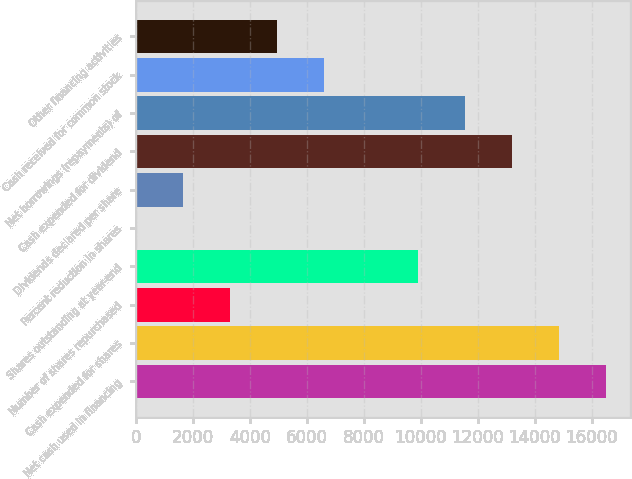Convert chart to OTSL. <chart><loc_0><loc_0><loc_500><loc_500><bar_chart><fcel>Net cash used in financing<fcel>Cash expended for shares<fcel>Number of shares repurchased<fcel>Shares outstanding at year-end<fcel>Percent reduction in shares<fcel>Dividends declared per share<fcel>Cash expended for dividend<fcel>Net borrowings (repayments) of<fcel>Cash received for common stock<fcel>Other financing activities<nl><fcel>16504<fcel>14853.8<fcel>3302.4<fcel>9903.2<fcel>2<fcel>1652.2<fcel>13203.6<fcel>11553.4<fcel>6602.8<fcel>4952.6<nl></chart> 